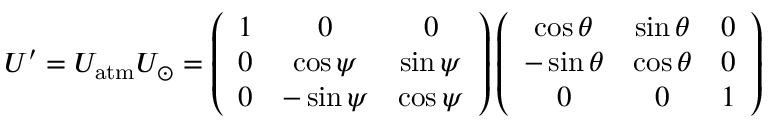Convert formula to latex. <formula><loc_0><loc_0><loc_500><loc_500>U ^ { \prime } = U _ { a t m } U _ { \odot } = \left ( \begin{array} { c c c } { 1 } & { 0 } & { 0 } \\ { 0 } & { \cos \psi } & { \sin \psi } \\ { 0 } & { - \sin \psi } & { \cos \psi } \end{array} \right ) \left ( \begin{array} { c c c } { \cos \theta } & { \sin \theta } & { 0 } \\ { - \sin \theta } & { \cos \theta } & { 0 } \\ { 0 } & { 0 } & { 1 } \end{array} \right )</formula> 